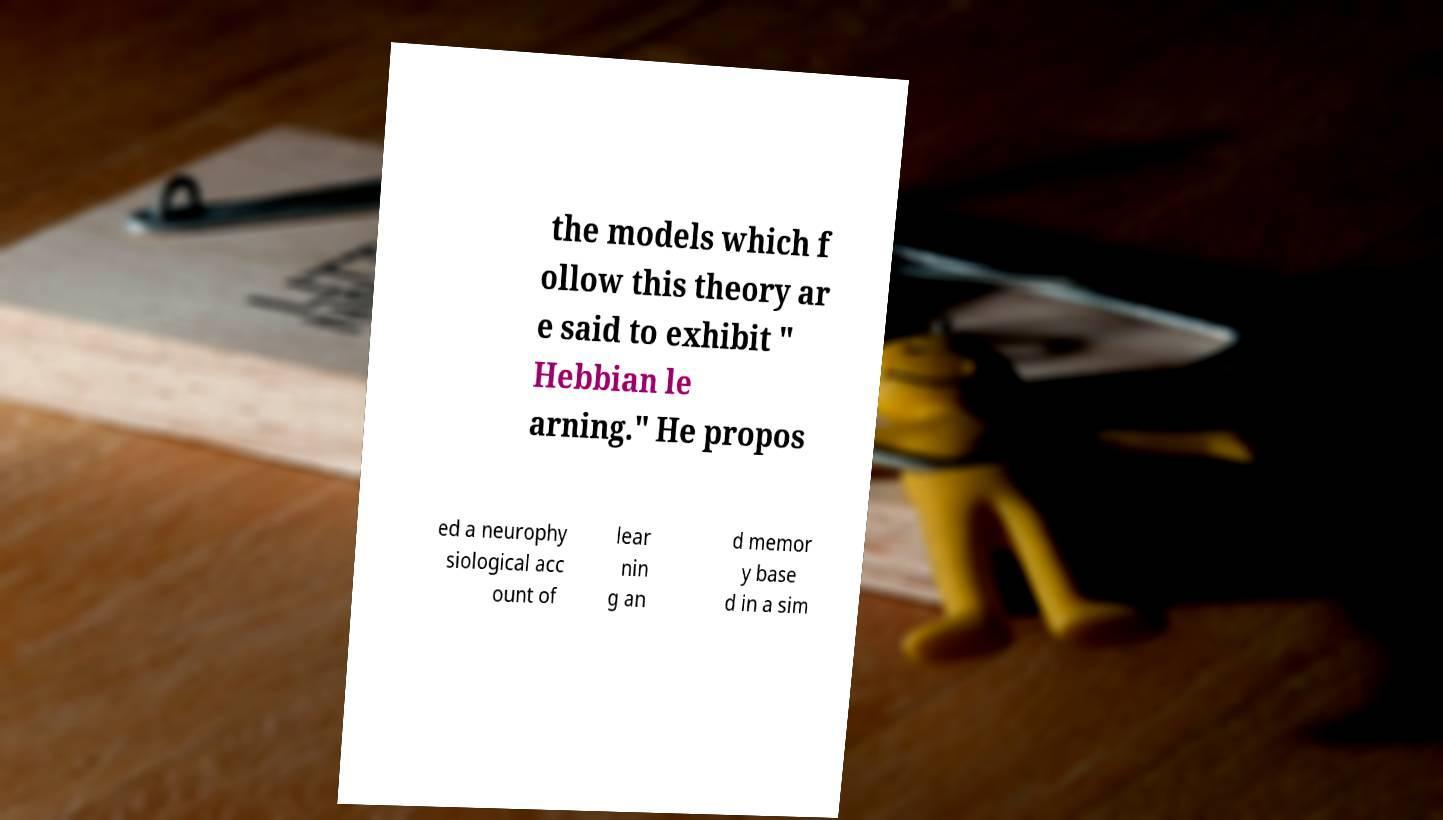Can you accurately transcribe the text from the provided image for me? the models which f ollow this theory ar e said to exhibit " Hebbian le arning." He propos ed a neurophy siological acc ount of lear nin g an d memor y base d in a sim 